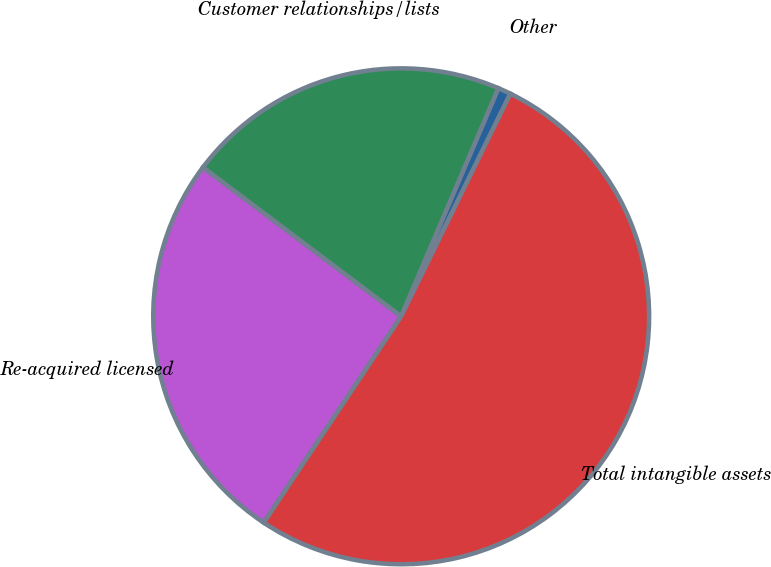<chart> <loc_0><loc_0><loc_500><loc_500><pie_chart><fcel>Re-acquired licensed<fcel>Customer relationships/lists<fcel>Other<fcel>Total intangible assets<nl><fcel>25.91%<fcel>21.16%<fcel>0.84%<fcel>52.09%<nl></chart> 